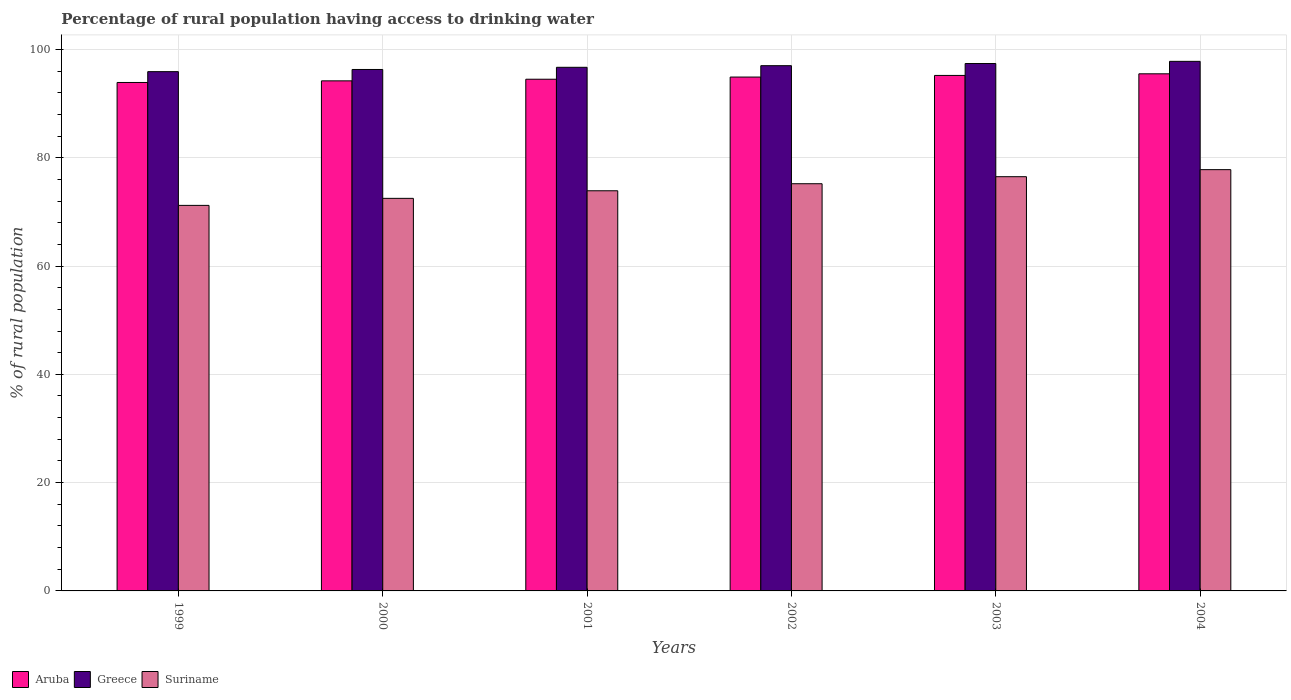How many different coloured bars are there?
Provide a short and direct response. 3. How many groups of bars are there?
Keep it short and to the point. 6. Are the number of bars per tick equal to the number of legend labels?
Offer a terse response. Yes. How many bars are there on the 4th tick from the left?
Give a very brief answer. 3. What is the label of the 4th group of bars from the left?
Your response must be concise. 2002. What is the percentage of rural population having access to drinking water in Suriname in 2004?
Make the answer very short. 77.8. Across all years, what is the maximum percentage of rural population having access to drinking water in Greece?
Give a very brief answer. 97.8. Across all years, what is the minimum percentage of rural population having access to drinking water in Suriname?
Provide a succinct answer. 71.2. What is the total percentage of rural population having access to drinking water in Suriname in the graph?
Your response must be concise. 447.1. What is the difference between the percentage of rural population having access to drinking water in Suriname in 2000 and that in 2004?
Your response must be concise. -5.3. What is the difference between the percentage of rural population having access to drinking water in Suriname in 1999 and the percentage of rural population having access to drinking water in Greece in 2004?
Ensure brevity in your answer.  -26.6. What is the average percentage of rural population having access to drinking water in Aruba per year?
Make the answer very short. 94.7. In the year 2002, what is the difference between the percentage of rural population having access to drinking water in Greece and percentage of rural population having access to drinking water in Aruba?
Provide a short and direct response. 2.1. What is the ratio of the percentage of rural population having access to drinking water in Greece in 2001 to that in 2002?
Make the answer very short. 1. Is the percentage of rural population having access to drinking water in Greece in 1999 less than that in 2000?
Your answer should be very brief. Yes. Is the difference between the percentage of rural population having access to drinking water in Greece in 2000 and 2003 greater than the difference between the percentage of rural population having access to drinking water in Aruba in 2000 and 2003?
Offer a terse response. No. What is the difference between the highest and the second highest percentage of rural population having access to drinking water in Aruba?
Offer a terse response. 0.3. What is the difference between the highest and the lowest percentage of rural population having access to drinking water in Suriname?
Provide a short and direct response. 6.6. In how many years, is the percentage of rural population having access to drinking water in Aruba greater than the average percentage of rural population having access to drinking water in Aruba taken over all years?
Your answer should be very brief. 3. What does the 3rd bar from the left in 1999 represents?
Your answer should be compact. Suriname. What does the 1st bar from the right in 1999 represents?
Your response must be concise. Suriname. Is it the case that in every year, the sum of the percentage of rural population having access to drinking water in Aruba and percentage of rural population having access to drinking water in Suriname is greater than the percentage of rural population having access to drinking water in Greece?
Provide a short and direct response. Yes. How many bars are there?
Provide a short and direct response. 18. Are all the bars in the graph horizontal?
Your answer should be compact. No. What is the difference between two consecutive major ticks on the Y-axis?
Provide a succinct answer. 20. Are the values on the major ticks of Y-axis written in scientific E-notation?
Offer a terse response. No. Does the graph contain any zero values?
Your answer should be compact. No. Where does the legend appear in the graph?
Give a very brief answer. Bottom left. How are the legend labels stacked?
Provide a short and direct response. Horizontal. What is the title of the graph?
Provide a succinct answer. Percentage of rural population having access to drinking water. What is the label or title of the X-axis?
Your answer should be very brief. Years. What is the label or title of the Y-axis?
Offer a terse response. % of rural population. What is the % of rural population of Aruba in 1999?
Make the answer very short. 93.9. What is the % of rural population in Greece in 1999?
Your response must be concise. 95.9. What is the % of rural population of Suriname in 1999?
Offer a very short reply. 71.2. What is the % of rural population of Aruba in 2000?
Ensure brevity in your answer.  94.2. What is the % of rural population of Greece in 2000?
Offer a very short reply. 96.3. What is the % of rural population of Suriname in 2000?
Offer a very short reply. 72.5. What is the % of rural population of Aruba in 2001?
Ensure brevity in your answer.  94.5. What is the % of rural population of Greece in 2001?
Ensure brevity in your answer.  96.7. What is the % of rural population in Suriname in 2001?
Make the answer very short. 73.9. What is the % of rural population in Aruba in 2002?
Ensure brevity in your answer.  94.9. What is the % of rural population of Greece in 2002?
Offer a terse response. 97. What is the % of rural population in Suriname in 2002?
Your answer should be compact. 75.2. What is the % of rural population of Aruba in 2003?
Offer a very short reply. 95.2. What is the % of rural population in Greece in 2003?
Your answer should be compact. 97.4. What is the % of rural population in Suriname in 2003?
Make the answer very short. 76.5. What is the % of rural population of Aruba in 2004?
Provide a succinct answer. 95.5. What is the % of rural population in Greece in 2004?
Make the answer very short. 97.8. What is the % of rural population of Suriname in 2004?
Offer a very short reply. 77.8. Across all years, what is the maximum % of rural population in Aruba?
Provide a short and direct response. 95.5. Across all years, what is the maximum % of rural population in Greece?
Give a very brief answer. 97.8. Across all years, what is the maximum % of rural population in Suriname?
Your response must be concise. 77.8. Across all years, what is the minimum % of rural population in Aruba?
Provide a short and direct response. 93.9. Across all years, what is the minimum % of rural population of Greece?
Ensure brevity in your answer.  95.9. Across all years, what is the minimum % of rural population of Suriname?
Provide a succinct answer. 71.2. What is the total % of rural population in Aruba in the graph?
Ensure brevity in your answer.  568.2. What is the total % of rural population in Greece in the graph?
Offer a terse response. 581.1. What is the total % of rural population in Suriname in the graph?
Provide a short and direct response. 447.1. What is the difference between the % of rural population in Suriname in 1999 and that in 2001?
Your response must be concise. -2.7. What is the difference between the % of rural population of Aruba in 1999 and that in 2002?
Your response must be concise. -1. What is the difference between the % of rural population of Greece in 1999 and that in 2003?
Your answer should be compact. -1.5. What is the difference between the % of rural population of Suriname in 1999 and that in 2004?
Your answer should be very brief. -6.6. What is the difference between the % of rural population of Aruba in 2000 and that in 2001?
Your response must be concise. -0.3. What is the difference between the % of rural population of Greece in 2000 and that in 2001?
Offer a terse response. -0.4. What is the difference between the % of rural population in Suriname in 2000 and that in 2001?
Provide a short and direct response. -1.4. What is the difference between the % of rural population of Aruba in 2000 and that in 2002?
Your response must be concise. -0.7. What is the difference between the % of rural population of Greece in 2000 and that in 2002?
Provide a succinct answer. -0.7. What is the difference between the % of rural population of Aruba in 2000 and that in 2003?
Provide a short and direct response. -1. What is the difference between the % of rural population in Aruba in 2001 and that in 2002?
Ensure brevity in your answer.  -0.4. What is the difference between the % of rural population in Greece in 2001 and that in 2004?
Provide a short and direct response. -1.1. What is the difference between the % of rural population in Suriname in 2001 and that in 2004?
Your answer should be compact. -3.9. What is the difference between the % of rural population of Aruba in 2002 and that in 2003?
Provide a short and direct response. -0.3. What is the difference between the % of rural population of Suriname in 2002 and that in 2003?
Provide a short and direct response. -1.3. What is the difference between the % of rural population in Suriname in 2003 and that in 2004?
Your answer should be very brief. -1.3. What is the difference between the % of rural population of Aruba in 1999 and the % of rural population of Suriname in 2000?
Provide a short and direct response. 21.4. What is the difference between the % of rural population of Greece in 1999 and the % of rural population of Suriname in 2000?
Offer a terse response. 23.4. What is the difference between the % of rural population in Aruba in 1999 and the % of rural population in Greece in 2001?
Offer a terse response. -2.8. What is the difference between the % of rural population in Aruba in 1999 and the % of rural population in Greece in 2002?
Ensure brevity in your answer.  -3.1. What is the difference between the % of rural population in Aruba in 1999 and the % of rural population in Suriname in 2002?
Provide a short and direct response. 18.7. What is the difference between the % of rural population of Greece in 1999 and the % of rural population of Suriname in 2002?
Your response must be concise. 20.7. What is the difference between the % of rural population in Aruba in 1999 and the % of rural population in Greece in 2003?
Offer a terse response. -3.5. What is the difference between the % of rural population in Aruba in 1999 and the % of rural population in Suriname in 2003?
Provide a short and direct response. 17.4. What is the difference between the % of rural population of Greece in 1999 and the % of rural population of Suriname in 2003?
Your response must be concise. 19.4. What is the difference between the % of rural population of Greece in 1999 and the % of rural population of Suriname in 2004?
Offer a very short reply. 18.1. What is the difference between the % of rural population of Aruba in 2000 and the % of rural population of Suriname in 2001?
Your answer should be compact. 20.3. What is the difference between the % of rural population in Greece in 2000 and the % of rural population in Suriname in 2001?
Your response must be concise. 22.4. What is the difference between the % of rural population of Aruba in 2000 and the % of rural population of Greece in 2002?
Ensure brevity in your answer.  -2.8. What is the difference between the % of rural population of Greece in 2000 and the % of rural population of Suriname in 2002?
Provide a short and direct response. 21.1. What is the difference between the % of rural population of Aruba in 2000 and the % of rural population of Greece in 2003?
Provide a succinct answer. -3.2. What is the difference between the % of rural population in Aruba in 2000 and the % of rural population in Suriname in 2003?
Keep it short and to the point. 17.7. What is the difference between the % of rural population in Greece in 2000 and the % of rural population in Suriname in 2003?
Make the answer very short. 19.8. What is the difference between the % of rural population in Greece in 2000 and the % of rural population in Suriname in 2004?
Your answer should be very brief. 18.5. What is the difference between the % of rural population of Aruba in 2001 and the % of rural population of Suriname in 2002?
Make the answer very short. 19.3. What is the difference between the % of rural population in Greece in 2001 and the % of rural population in Suriname in 2002?
Make the answer very short. 21.5. What is the difference between the % of rural population of Greece in 2001 and the % of rural population of Suriname in 2003?
Offer a very short reply. 20.2. What is the difference between the % of rural population of Aruba in 2001 and the % of rural population of Suriname in 2004?
Ensure brevity in your answer.  16.7. What is the difference between the % of rural population in Aruba in 2002 and the % of rural population in Greece in 2003?
Make the answer very short. -2.5. What is the difference between the % of rural population of Aruba in 2002 and the % of rural population of Suriname in 2003?
Keep it short and to the point. 18.4. What is the difference between the % of rural population in Aruba in 2002 and the % of rural population in Greece in 2004?
Your response must be concise. -2.9. What is the difference between the % of rural population in Greece in 2002 and the % of rural population in Suriname in 2004?
Ensure brevity in your answer.  19.2. What is the difference between the % of rural population in Aruba in 2003 and the % of rural population in Suriname in 2004?
Provide a short and direct response. 17.4. What is the difference between the % of rural population in Greece in 2003 and the % of rural population in Suriname in 2004?
Provide a succinct answer. 19.6. What is the average % of rural population in Aruba per year?
Your answer should be very brief. 94.7. What is the average % of rural population of Greece per year?
Provide a succinct answer. 96.85. What is the average % of rural population of Suriname per year?
Keep it short and to the point. 74.52. In the year 1999, what is the difference between the % of rural population in Aruba and % of rural population in Greece?
Make the answer very short. -2. In the year 1999, what is the difference between the % of rural population in Aruba and % of rural population in Suriname?
Provide a succinct answer. 22.7. In the year 1999, what is the difference between the % of rural population in Greece and % of rural population in Suriname?
Make the answer very short. 24.7. In the year 2000, what is the difference between the % of rural population of Aruba and % of rural population of Greece?
Give a very brief answer. -2.1. In the year 2000, what is the difference between the % of rural population in Aruba and % of rural population in Suriname?
Give a very brief answer. 21.7. In the year 2000, what is the difference between the % of rural population of Greece and % of rural population of Suriname?
Ensure brevity in your answer.  23.8. In the year 2001, what is the difference between the % of rural population of Aruba and % of rural population of Greece?
Keep it short and to the point. -2.2. In the year 2001, what is the difference between the % of rural population in Aruba and % of rural population in Suriname?
Your response must be concise. 20.6. In the year 2001, what is the difference between the % of rural population of Greece and % of rural population of Suriname?
Provide a succinct answer. 22.8. In the year 2002, what is the difference between the % of rural population of Aruba and % of rural population of Greece?
Your response must be concise. -2.1. In the year 2002, what is the difference between the % of rural population of Aruba and % of rural population of Suriname?
Provide a short and direct response. 19.7. In the year 2002, what is the difference between the % of rural population in Greece and % of rural population in Suriname?
Your answer should be compact. 21.8. In the year 2003, what is the difference between the % of rural population of Greece and % of rural population of Suriname?
Provide a short and direct response. 20.9. In the year 2004, what is the difference between the % of rural population in Aruba and % of rural population in Suriname?
Keep it short and to the point. 17.7. What is the ratio of the % of rural population in Suriname in 1999 to that in 2000?
Your response must be concise. 0.98. What is the ratio of the % of rural population in Greece in 1999 to that in 2001?
Offer a very short reply. 0.99. What is the ratio of the % of rural population in Suriname in 1999 to that in 2001?
Your response must be concise. 0.96. What is the ratio of the % of rural population of Aruba in 1999 to that in 2002?
Your answer should be compact. 0.99. What is the ratio of the % of rural population of Greece in 1999 to that in 2002?
Offer a terse response. 0.99. What is the ratio of the % of rural population of Suriname in 1999 to that in 2002?
Offer a terse response. 0.95. What is the ratio of the % of rural population in Aruba in 1999 to that in 2003?
Offer a very short reply. 0.99. What is the ratio of the % of rural population of Greece in 1999 to that in 2003?
Your answer should be compact. 0.98. What is the ratio of the % of rural population of Suriname in 1999 to that in 2003?
Ensure brevity in your answer.  0.93. What is the ratio of the % of rural population of Aruba in 1999 to that in 2004?
Ensure brevity in your answer.  0.98. What is the ratio of the % of rural population of Greece in 1999 to that in 2004?
Give a very brief answer. 0.98. What is the ratio of the % of rural population in Suriname in 1999 to that in 2004?
Provide a succinct answer. 0.92. What is the ratio of the % of rural population of Greece in 2000 to that in 2001?
Provide a short and direct response. 1. What is the ratio of the % of rural population of Suriname in 2000 to that in 2001?
Keep it short and to the point. 0.98. What is the ratio of the % of rural population in Aruba in 2000 to that in 2002?
Ensure brevity in your answer.  0.99. What is the ratio of the % of rural population in Greece in 2000 to that in 2002?
Provide a succinct answer. 0.99. What is the ratio of the % of rural population in Suriname in 2000 to that in 2002?
Make the answer very short. 0.96. What is the ratio of the % of rural population in Greece in 2000 to that in 2003?
Keep it short and to the point. 0.99. What is the ratio of the % of rural population in Suriname in 2000 to that in 2003?
Keep it short and to the point. 0.95. What is the ratio of the % of rural population of Aruba in 2000 to that in 2004?
Keep it short and to the point. 0.99. What is the ratio of the % of rural population of Greece in 2000 to that in 2004?
Make the answer very short. 0.98. What is the ratio of the % of rural population of Suriname in 2000 to that in 2004?
Offer a terse response. 0.93. What is the ratio of the % of rural population of Greece in 2001 to that in 2002?
Keep it short and to the point. 1. What is the ratio of the % of rural population in Suriname in 2001 to that in 2002?
Make the answer very short. 0.98. What is the ratio of the % of rural population of Greece in 2001 to that in 2003?
Your answer should be compact. 0.99. What is the ratio of the % of rural population in Suriname in 2001 to that in 2003?
Ensure brevity in your answer.  0.97. What is the ratio of the % of rural population of Suriname in 2001 to that in 2004?
Ensure brevity in your answer.  0.95. What is the ratio of the % of rural population in Aruba in 2002 to that in 2004?
Offer a very short reply. 0.99. What is the ratio of the % of rural population in Suriname in 2002 to that in 2004?
Offer a very short reply. 0.97. What is the ratio of the % of rural population of Greece in 2003 to that in 2004?
Ensure brevity in your answer.  1. What is the ratio of the % of rural population in Suriname in 2003 to that in 2004?
Your response must be concise. 0.98. What is the difference between the highest and the lowest % of rural population of Aruba?
Keep it short and to the point. 1.6. What is the difference between the highest and the lowest % of rural population of Greece?
Give a very brief answer. 1.9. What is the difference between the highest and the lowest % of rural population in Suriname?
Your answer should be compact. 6.6. 